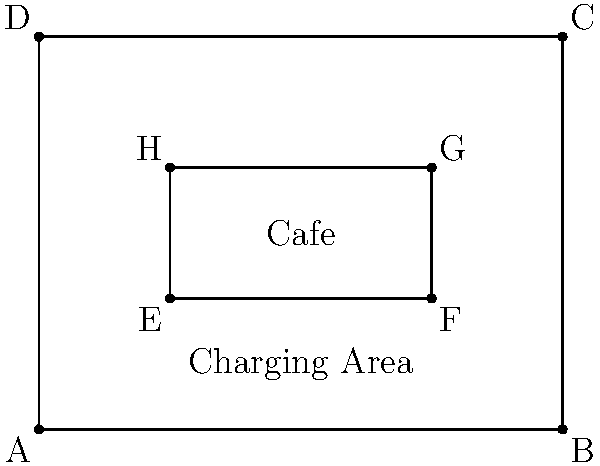Your rectangular cafe has dimensions of 8m by 6m, with a central rectangular charging area of 4m by 2m. If you want to place circular charging stations with a radius of 0.5m at each corner of the charging area, what is the minimum distance between the centers of any two adjacent charging stations to ensure they don't overlap? To solve this problem, we need to follow these steps:

1) First, we need to identify the corners of the charging area. These are points E, F, G, and H in the diagram.

2) The charging stations will be placed at these corners. Since they are circular with a radius of 0.5m, their centers will be at these exact points.

3) To ensure the charging stations don't overlap, the distance between their centers must be at least twice their radius. This is because if the distance was less than this, the circles would intersect.

4) The minimum distance will be between adjacent corners of the charging area. We need to calculate this distance.

5) The charging area is a rectangle measuring 4m by 2m. We can use the Pythagorean theorem to calculate the diagonal distance:

   $$d = \sqrt{4^2 + 2^2} = \sqrt{16 + 4} = \sqrt{20} = 2\sqrt{5}$$

6) This diagonal distance (between opposite corners) is the hypotenuse of the right triangle formed by the sides of the charging area. The distance between adjacent corners will be the length of the sides of this rectangle.

7) The shorter side of the charging area is 2m, and the longer side is 4m.

8) Therefore, the minimum distance between the centers of any two adjacent charging stations is 2m (the shorter side of the rectangle).

9) We need to verify if this distance is sufficient to prevent overlap:
   
   Minimum required distance = 2 * radius = 2 * 0.5m = 1m

   Since 2m > 1m, this distance is sufficient to prevent overlap.
Answer: 2m 